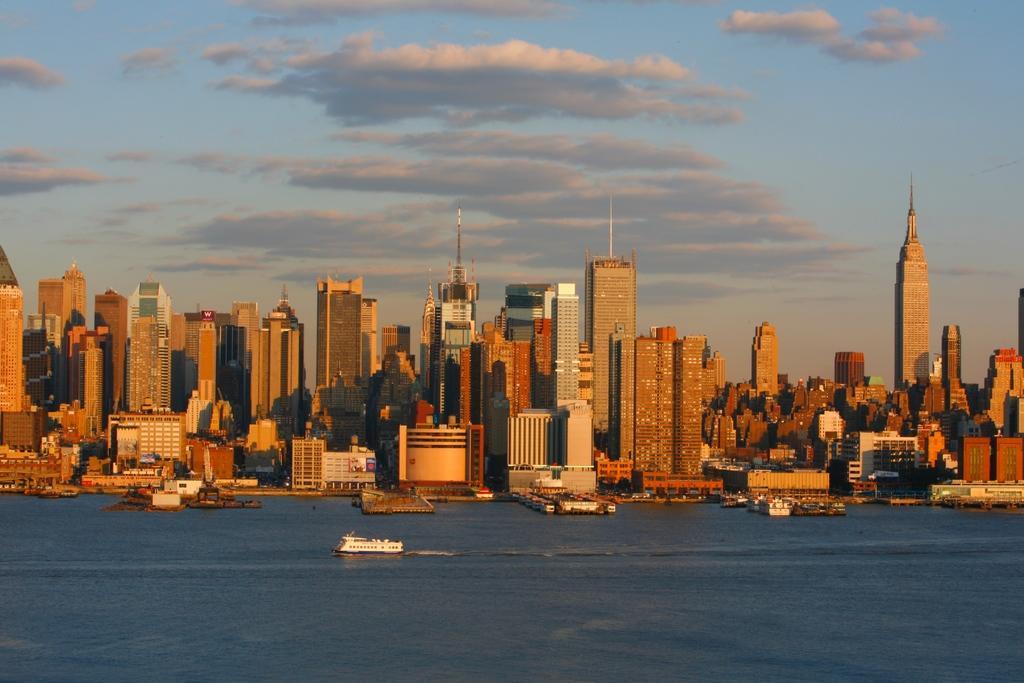Please provide a concise description of this image. In this picture I can see buildings and few boats in the water and I can see a blue cloudy sky. 